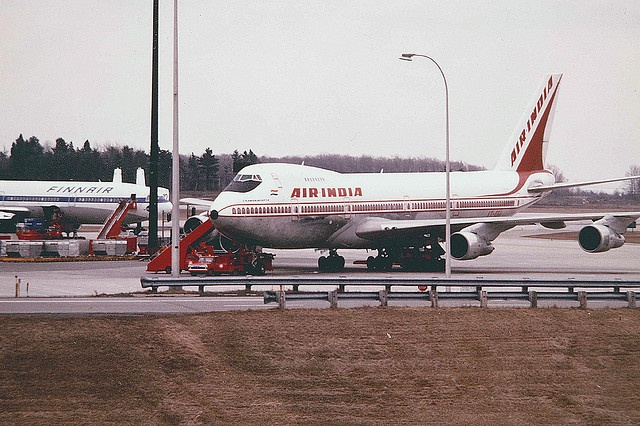Describe the objects in this image and their specific colors. I can see airplane in lightgray, black, gray, and darkgray tones, airplane in lightgray, black, gray, and darkgray tones, and truck in lightgray, maroon, black, brown, and lavender tones in this image. 